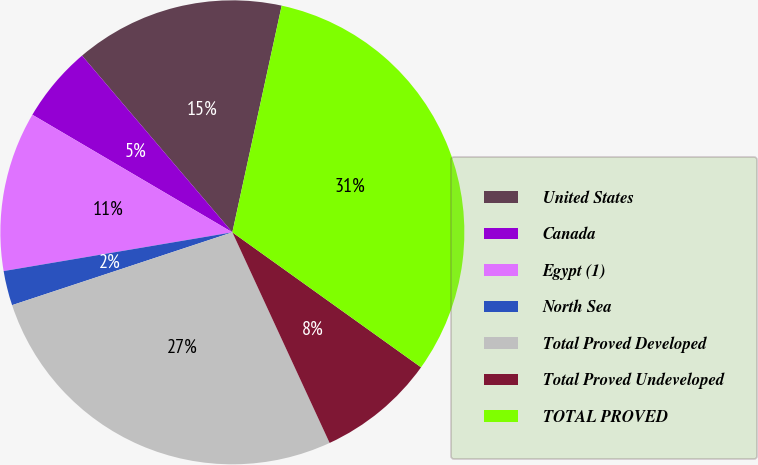Convert chart to OTSL. <chart><loc_0><loc_0><loc_500><loc_500><pie_chart><fcel>United States<fcel>Canada<fcel>Egypt (1)<fcel>North Sea<fcel>Total Proved Developed<fcel>Total Proved Undeveloped<fcel>TOTAL PROVED<nl><fcel>14.63%<fcel>5.32%<fcel>11.13%<fcel>2.41%<fcel>26.8%<fcel>8.23%<fcel>31.47%<nl></chart> 